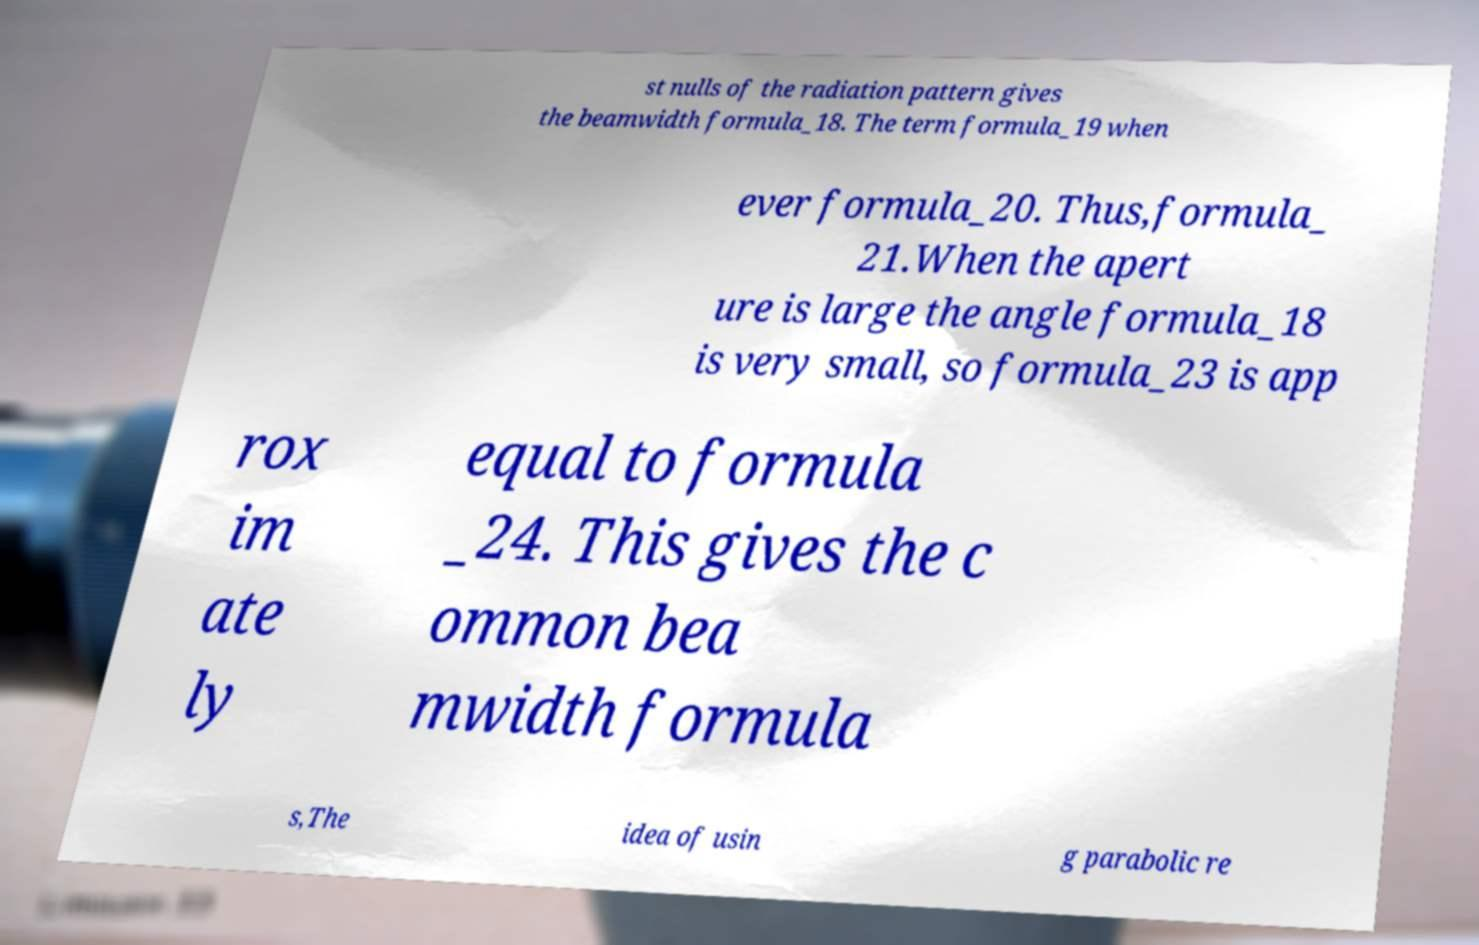For documentation purposes, I need the text within this image transcribed. Could you provide that? st nulls of the radiation pattern gives the beamwidth formula_18. The term formula_19 when ever formula_20. Thus,formula_ 21.When the apert ure is large the angle formula_18 is very small, so formula_23 is app rox im ate ly equal to formula _24. This gives the c ommon bea mwidth formula s,The idea of usin g parabolic re 